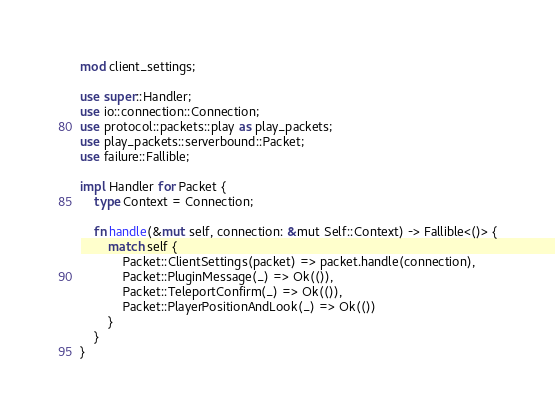<code> <loc_0><loc_0><loc_500><loc_500><_Rust_>mod client_settings;

use super::Handler;
use io::connection::Connection;
use protocol::packets::play as play_packets;
use play_packets::serverbound::Packet;
use failure::Fallible;

impl Handler for Packet {
    type Context = Connection;

    fn handle(&mut self, connection: &mut Self::Context) -> Fallible<()> {
        match self {
            Packet::ClientSettings(packet) => packet.handle(connection),
            Packet::PluginMessage(_) => Ok(()),
            Packet::TeleportConfirm(_) => Ok(()),
            Packet::PlayerPositionAndLook(_) => Ok(())
        }
    }
}
</code> 